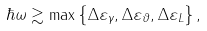Convert formula to latex. <formula><loc_0><loc_0><loc_500><loc_500>\hbar { \omega } \gtrsim \max \left \{ \Delta \varepsilon _ { \gamma } , \Delta \varepsilon _ { \vartheta } , \Delta \varepsilon _ { L } \right \} ,</formula> 